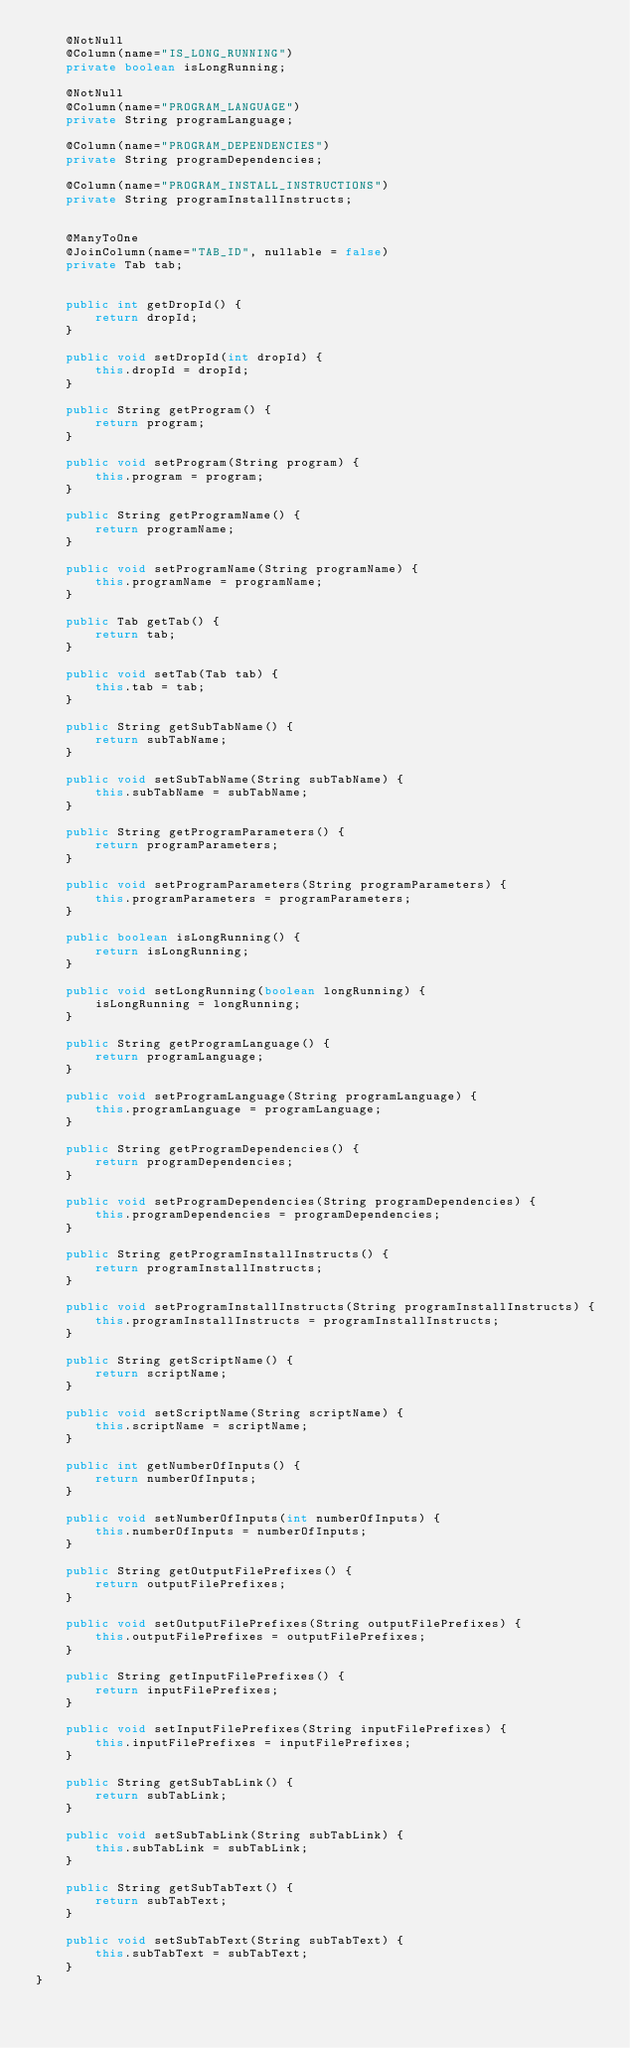Convert code to text. <code><loc_0><loc_0><loc_500><loc_500><_Java_>    @NotNull
    @Column(name="IS_LONG_RUNNING")
    private boolean isLongRunning;

    @NotNull
    @Column(name="PROGRAM_LANGUAGE")
    private String programLanguage;

    @Column(name="PROGRAM_DEPENDENCIES")
    private String programDependencies;

    @Column(name="PROGRAM_INSTALL_INSTRUCTIONS")
    private String programInstallInstructs;


    @ManyToOne
    @JoinColumn(name="TAB_ID", nullable = false)
    private Tab tab;


    public int getDropId() {
        return dropId;
    }

    public void setDropId(int dropId) {
        this.dropId = dropId;
    }

    public String getProgram() {
        return program;
    }

    public void setProgram(String program) {
        this.program = program;
    }

    public String getProgramName() {
        return programName;
    }

    public void setProgramName(String programName) {
        this.programName = programName;
    }

    public Tab getTab() {
        return tab;
    }

    public void setTab(Tab tab) {
        this.tab = tab;
    }

    public String getSubTabName() {
        return subTabName;
    }

    public void setSubTabName(String subTabName) {
        this.subTabName = subTabName;
    }

    public String getProgramParameters() {
        return programParameters;
    }

    public void setProgramParameters(String programParameters) {
        this.programParameters = programParameters;
    }

    public boolean isLongRunning() {
        return isLongRunning;
    }

    public void setLongRunning(boolean longRunning) {
        isLongRunning = longRunning;
    }

    public String getProgramLanguage() {
        return programLanguage;
    }

    public void setProgramLanguage(String programLanguage) {
        this.programLanguage = programLanguage;
    }

    public String getProgramDependencies() {
        return programDependencies;
    }

    public void setProgramDependencies(String programDependencies) {
        this.programDependencies = programDependencies;
    }

    public String getProgramInstallInstructs() {
        return programInstallInstructs;
    }

    public void setProgramInstallInstructs(String programInstallInstructs) {
        this.programInstallInstructs = programInstallInstructs;
    }

    public String getScriptName() {
        return scriptName;
    }

    public void setScriptName(String scriptName) {
        this.scriptName = scriptName;
    }

    public int getNumberOfInputs() {
        return numberOfInputs;
    }

    public void setNumberOfInputs(int numberOfInputs) {
        this.numberOfInputs = numberOfInputs;
    }

    public String getOutputFilePrefixes() {
        return outputFilePrefixes;
    }

    public void setOutputFilePrefixes(String outputFilePrefixes) {
        this.outputFilePrefixes = outputFilePrefixes;
    }

    public String getInputFilePrefixes() {
        return inputFilePrefixes;
    }

    public void setInputFilePrefixes(String inputFilePrefixes) {
        this.inputFilePrefixes = inputFilePrefixes;
    }

    public String getSubTabLink() {
        return subTabLink;
    }

    public void setSubTabLink(String subTabLink) {
        this.subTabLink = subTabLink;
    }

    public String getSubTabText() {
        return subTabText;
    }

    public void setSubTabText(String subTabText) {
        this.subTabText = subTabText;
    }
}
</code> 